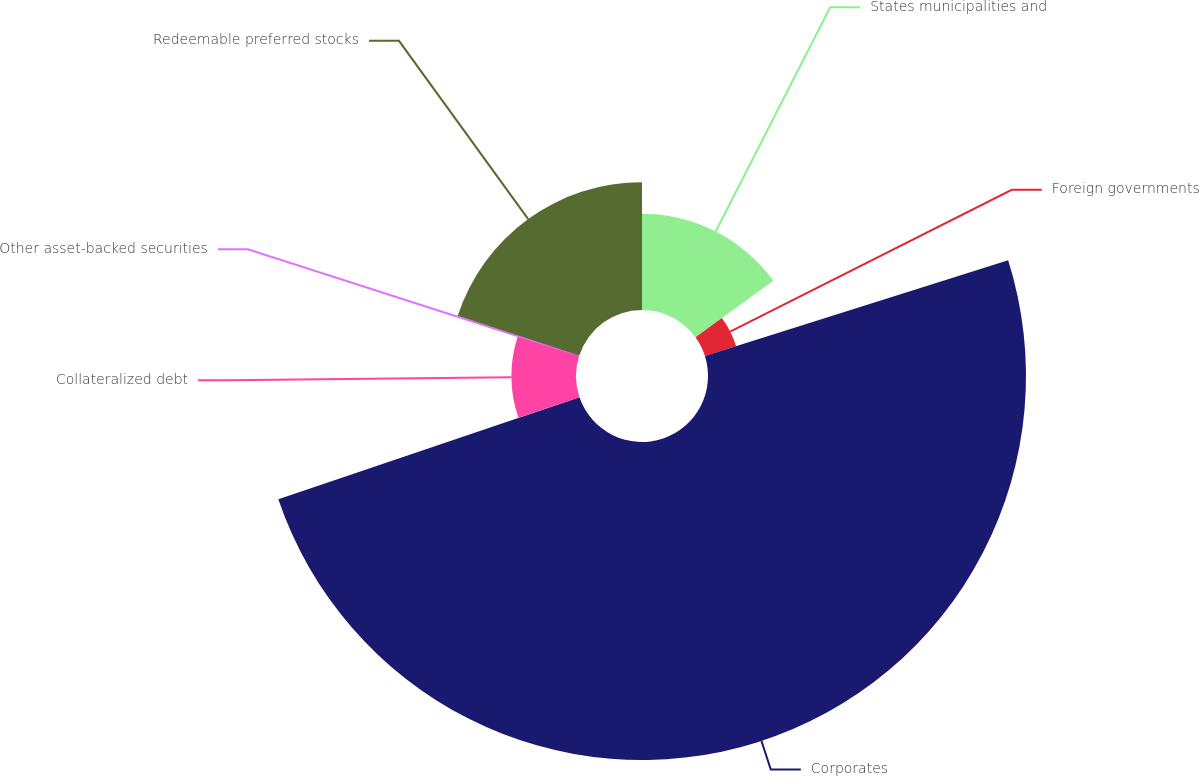Convert chart to OTSL. <chart><loc_0><loc_0><loc_500><loc_500><pie_chart><fcel>States municipalities and<fcel>Foreign governments<fcel>Corporates<fcel>Collateralized debt<fcel>Other asset-backed securities<fcel>Redeemable preferred stocks<nl><fcel>15.02%<fcel>5.11%<fcel>49.67%<fcel>10.07%<fcel>0.16%<fcel>19.97%<nl></chart> 